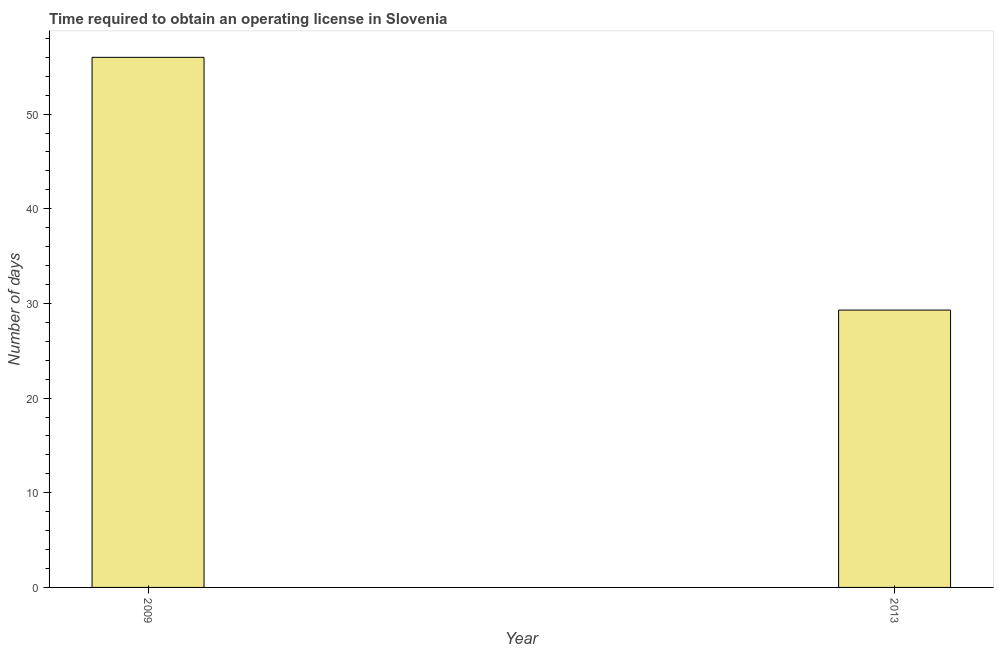Does the graph contain any zero values?
Offer a terse response. No. Does the graph contain grids?
Make the answer very short. No. What is the title of the graph?
Provide a short and direct response. Time required to obtain an operating license in Slovenia. What is the label or title of the X-axis?
Give a very brief answer. Year. What is the label or title of the Y-axis?
Make the answer very short. Number of days. What is the number of days to obtain operating license in 2013?
Your response must be concise. 29.3. Across all years, what is the minimum number of days to obtain operating license?
Offer a very short reply. 29.3. In which year was the number of days to obtain operating license maximum?
Make the answer very short. 2009. What is the sum of the number of days to obtain operating license?
Offer a very short reply. 85.3. What is the difference between the number of days to obtain operating license in 2009 and 2013?
Provide a short and direct response. 26.7. What is the average number of days to obtain operating license per year?
Provide a short and direct response. 42.65. What is the median number of days to obtain operating license?
Your response must be concise. 42.65. In how many years, is the number of days to obtain operating license greater than 18 days?
Your response must be concise. 2. What is the ratio of the number of days to obtain operating license in 2009 to that in 2013?
Provide a short and direct response. 1.91. In how many years, is the number of days to obtain operating license greater than the average number of days to obtain operating license taken over all years?
Keep it short and to the point. 1. Are all the bars in the graph horizontal?
Keep it short and to the point. No. How many years are there in the graph?
Provide a short and direct response. 2. What is the Number of days in 2009?
Offer a very short reply. 56. What is the Number of days of 2013?
Your answer should be very brief. 29.3. What is the difference between the Number of days in 2009 and 2013?
Make the answer very short. 26.7. What is the ratio of the Number of days in 2009 to that in 2013?
Your answer should be compact. 1.91. 